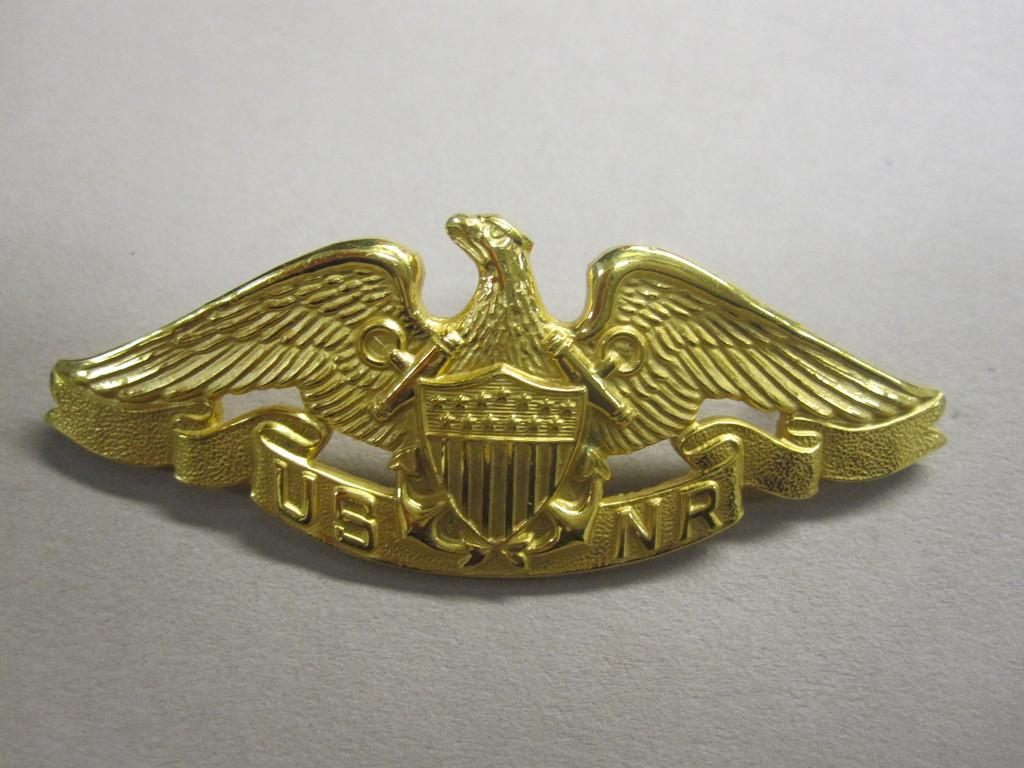What is the main object in the image? There is a badge in the image. What is the color of the badge? The badge is in golden color. What symbol or figure is present on the badge? There is an eagle on the badge. What type of doll is holding the degree in the image? There is no doll or degree present in the image; it only features a badge with an eagle on it. 